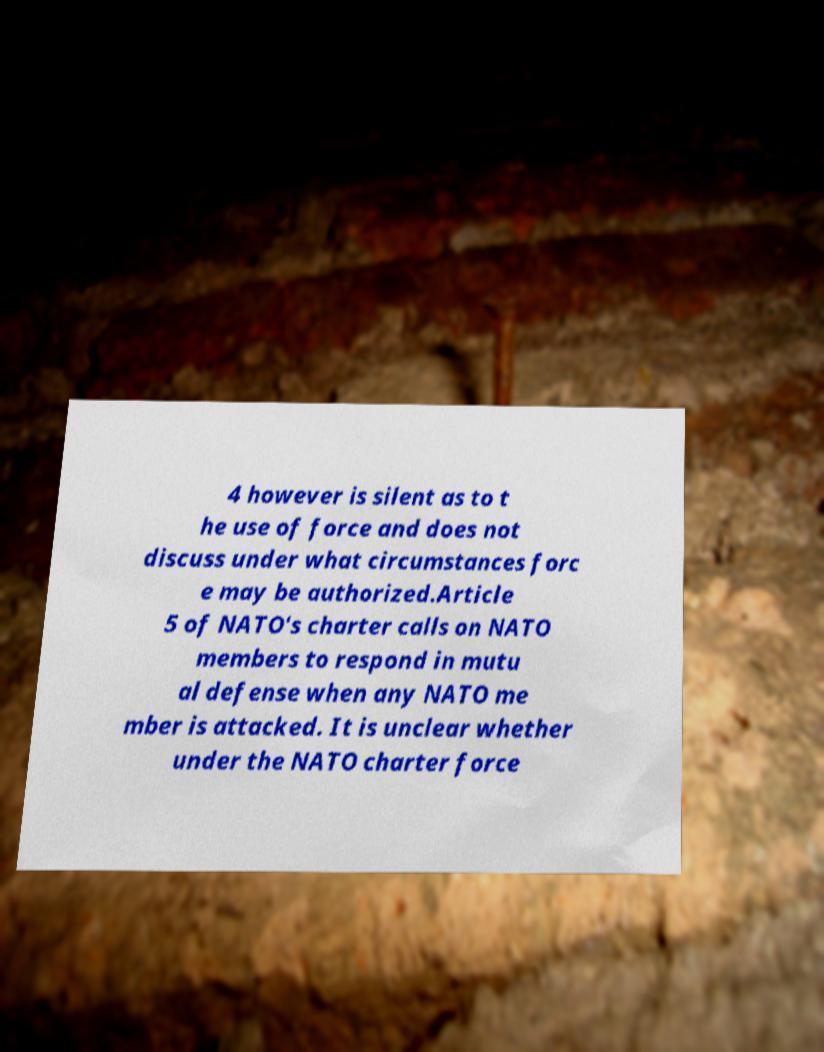Could you assist in decoding the text presented in this image and type it out clearly? 4 however is silent as to t he use of force and does not discuss under what circumstances forc e may be authorized.Article 5 of NATO's charter calls on NATO members to respond in mutu al defense when any NATO me mber is attacked. It is unclear whether under the NATO charter force 